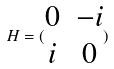<formula> <loc_0><loc_0><loc_500><loc_500>H = ( \begin{matrix} 0 & - i \\ i & 0 \end{matrix} )</formula> 